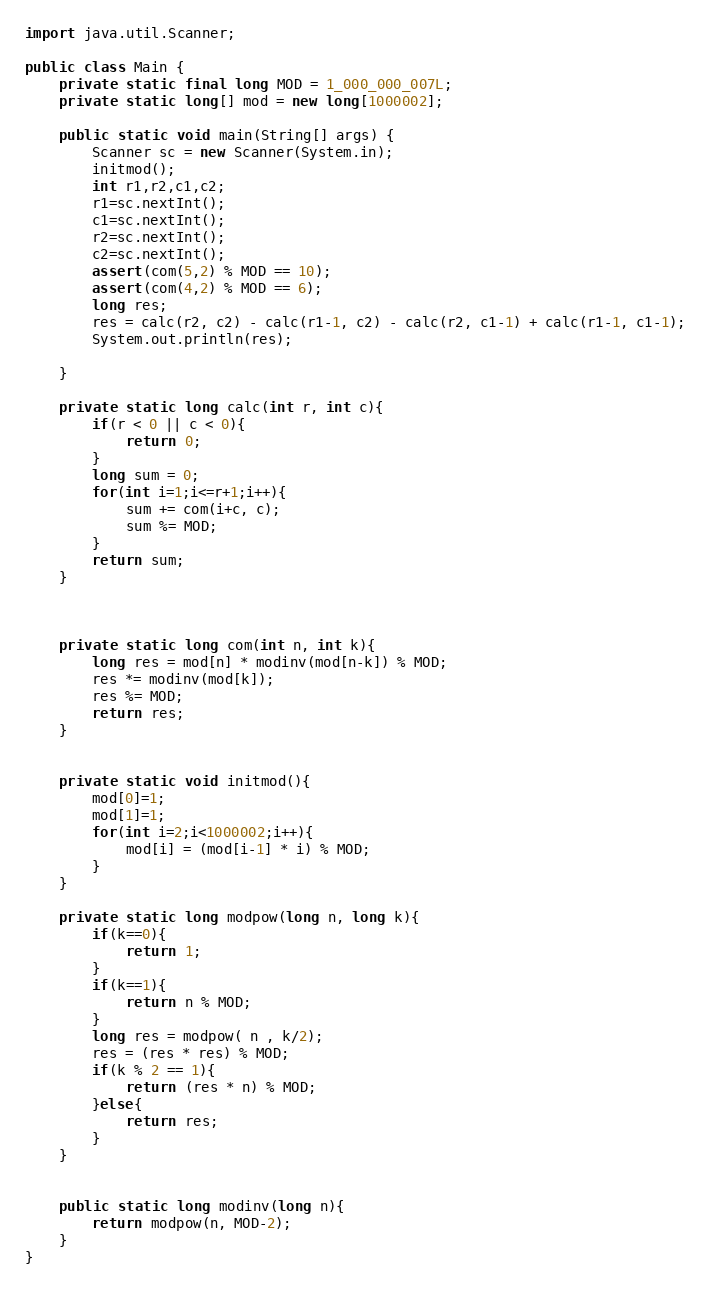<code> <loc_0><loc_0><loc_500><loc_500><_Java_>import java.util.Scanner;

public class Main {
    private static final long MOD = 1_000_000_007L;
    private static long[] mod = new long[1000002];

    public static void main(String[] args) {
        Scanner sc = new Scanner(System.in);
        initmod();
        int r1,r2,c1,c2;
        r1=sc.nextInt();
        c1=sc.nextInt();
        r2=sc.nextInt();
        c2=sc.nextInt();
        assert(com(5,2) % MOD == 10);
        assert(com(4,2) % MOD == 6);
        long res;
        res = calc(r2, c2) - calc(r1-1, c2) - calc(r2, c1-1) + calc(r1-1, c1-1);
        System.out.println(res);

    }

    private static long calc(int r, int c){
        if(r < 0 || c < 0){
            return 0;
        }
        long sum = 0;
        for(int i=1;i<=r+1;i++){
            sum += com(i+c, c);
            sum %= MOD;
        }
        return sum;
    }



    private static long com(int n, int k){
        long res = mod[n] * modinv(mod[n-k]) % MOD;
        res *= modinv(mod[k]);
        res %= MOD;
        return res;
    }


    private static void initmod(){
        mod[0]=1;
        mod[1]=1;
        for(int i=2;i<1000002;i++){
            mod[i] = (mod[i-1] * i) % MOD;
        }
    }

    private static long modpow(long n, long k){
        if(k==0){
            return 1;
        }
        if(k==1){
            return n % MOD;
        }
        long res = modpow( n , k/2);
        res = (res * res) % MOD;
        if(k % 2 == 1){
            return (res * n) % MOD;
        }else{
            return res;
        }
    }


    public static long modinv(long n){
        return modpow(n, MOD-2);
    }
}
</code> 